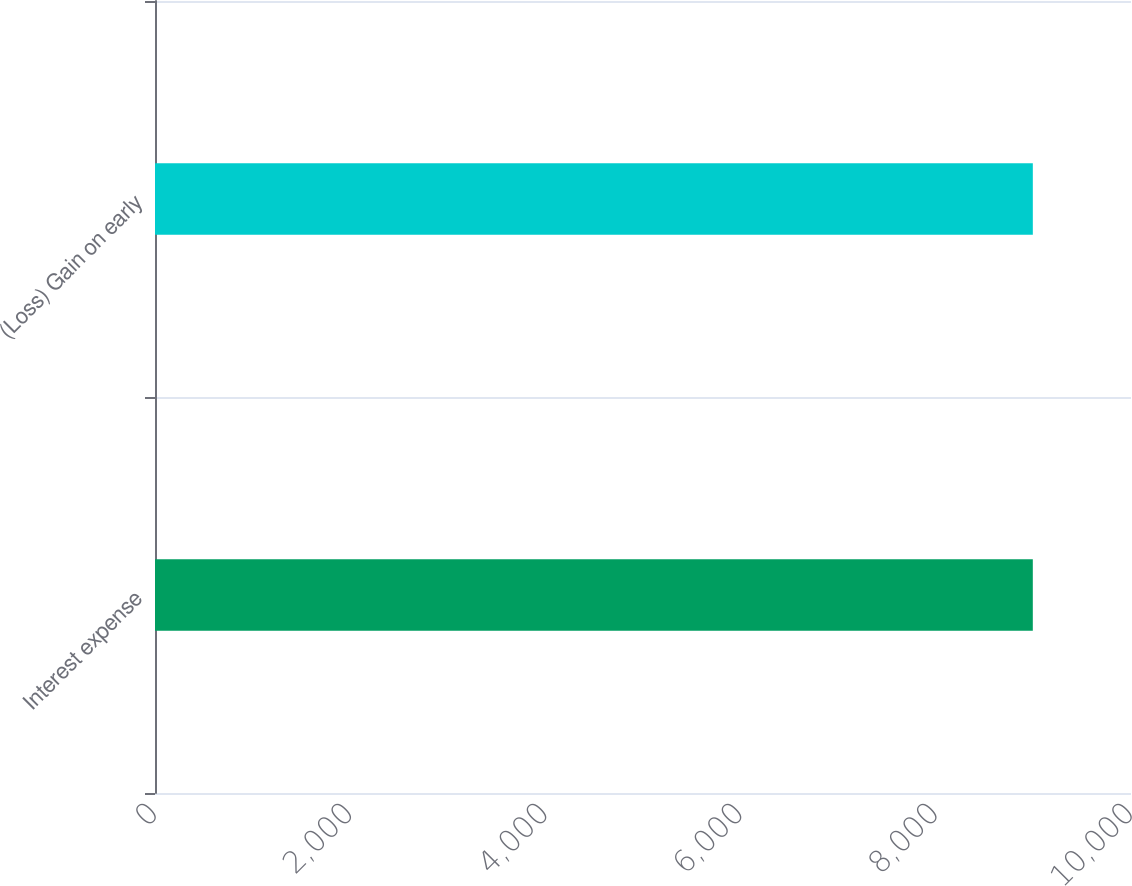Convert chart to OTSL. <chart><loc_0><loc_0><loc_500><loc_500><bar_chart><fcel>Interest expense<fcel>(Loss) Gain on early<nl><fcel>8994<fcel>8994.1<nl></chart> 